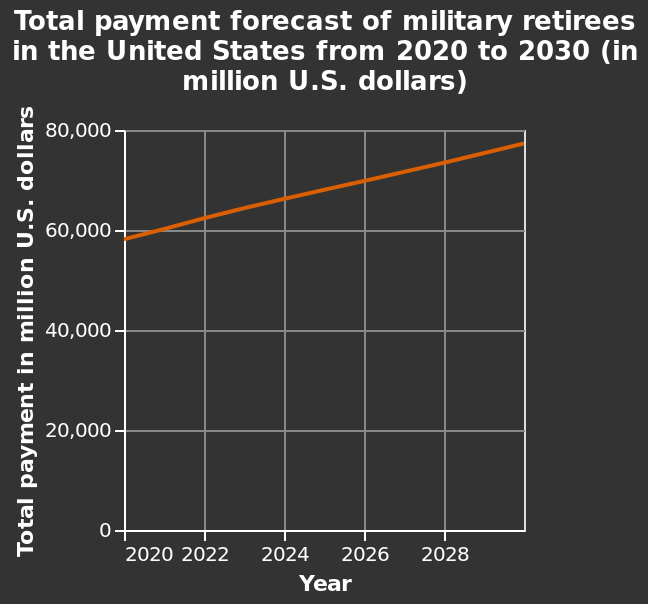<image>
What is the title of the line graph? The title of the line graph is "Total payment forecast of military retirees in the United States from 2020 to 2030 (in million U.S. dollars)." Does the total payment increase or decrease every year?  The total payment increases every year. 